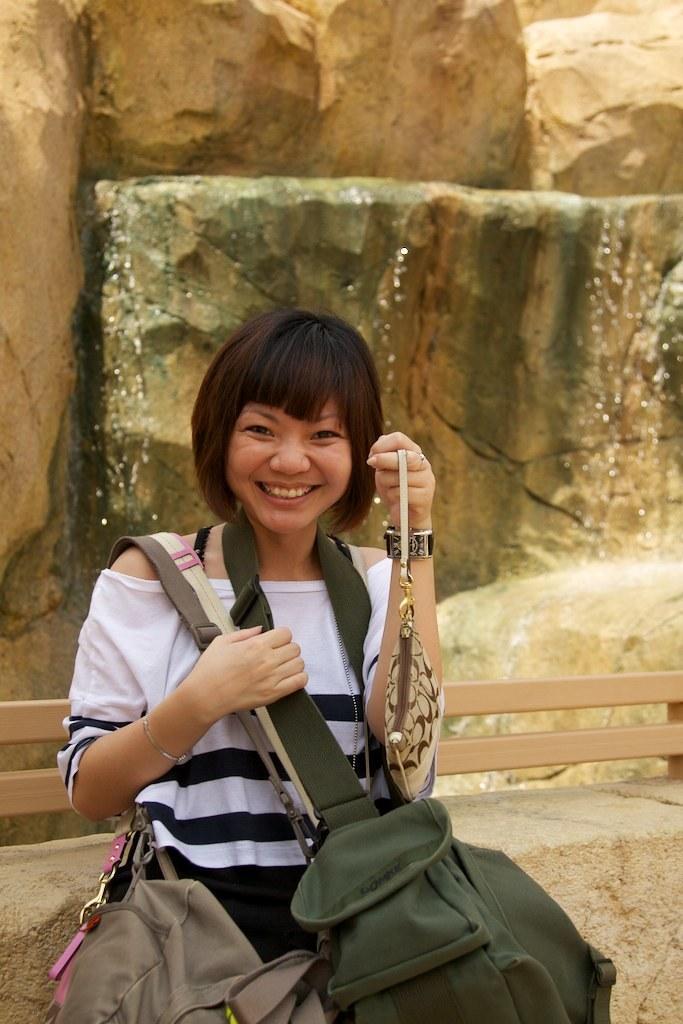Describe this image in one or two sentences. In this image there is a woman standing wearing bags, in the background there are rocks. 